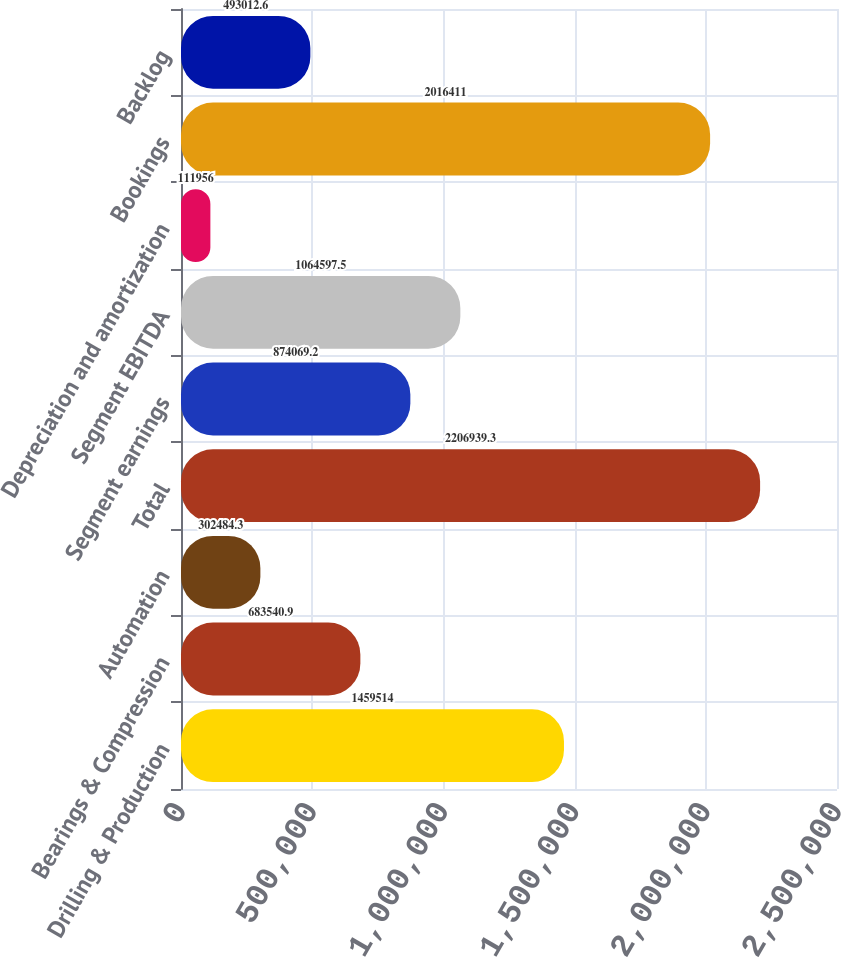<chart> <loc_0><loc_0><loc_500><loc_500><bar_chart><fcel>Drilling & Production<fcel>Bearings & Compression<fcel>Automation<fcel>Total<fcel>Segment earnings<fcel>Segment EBITDA<fcel>Depreciation and amortization<fcel>Bookings<fcel>Backlog<nl><fcel>1.45951e+06<fcel>683541<fcel>302484<fcel>2.20694e+06<fcel>874069<fcel>1.0646e+06<fcel>111956<fcel>2.01641e+06<fcel>493013<nl></chart> 